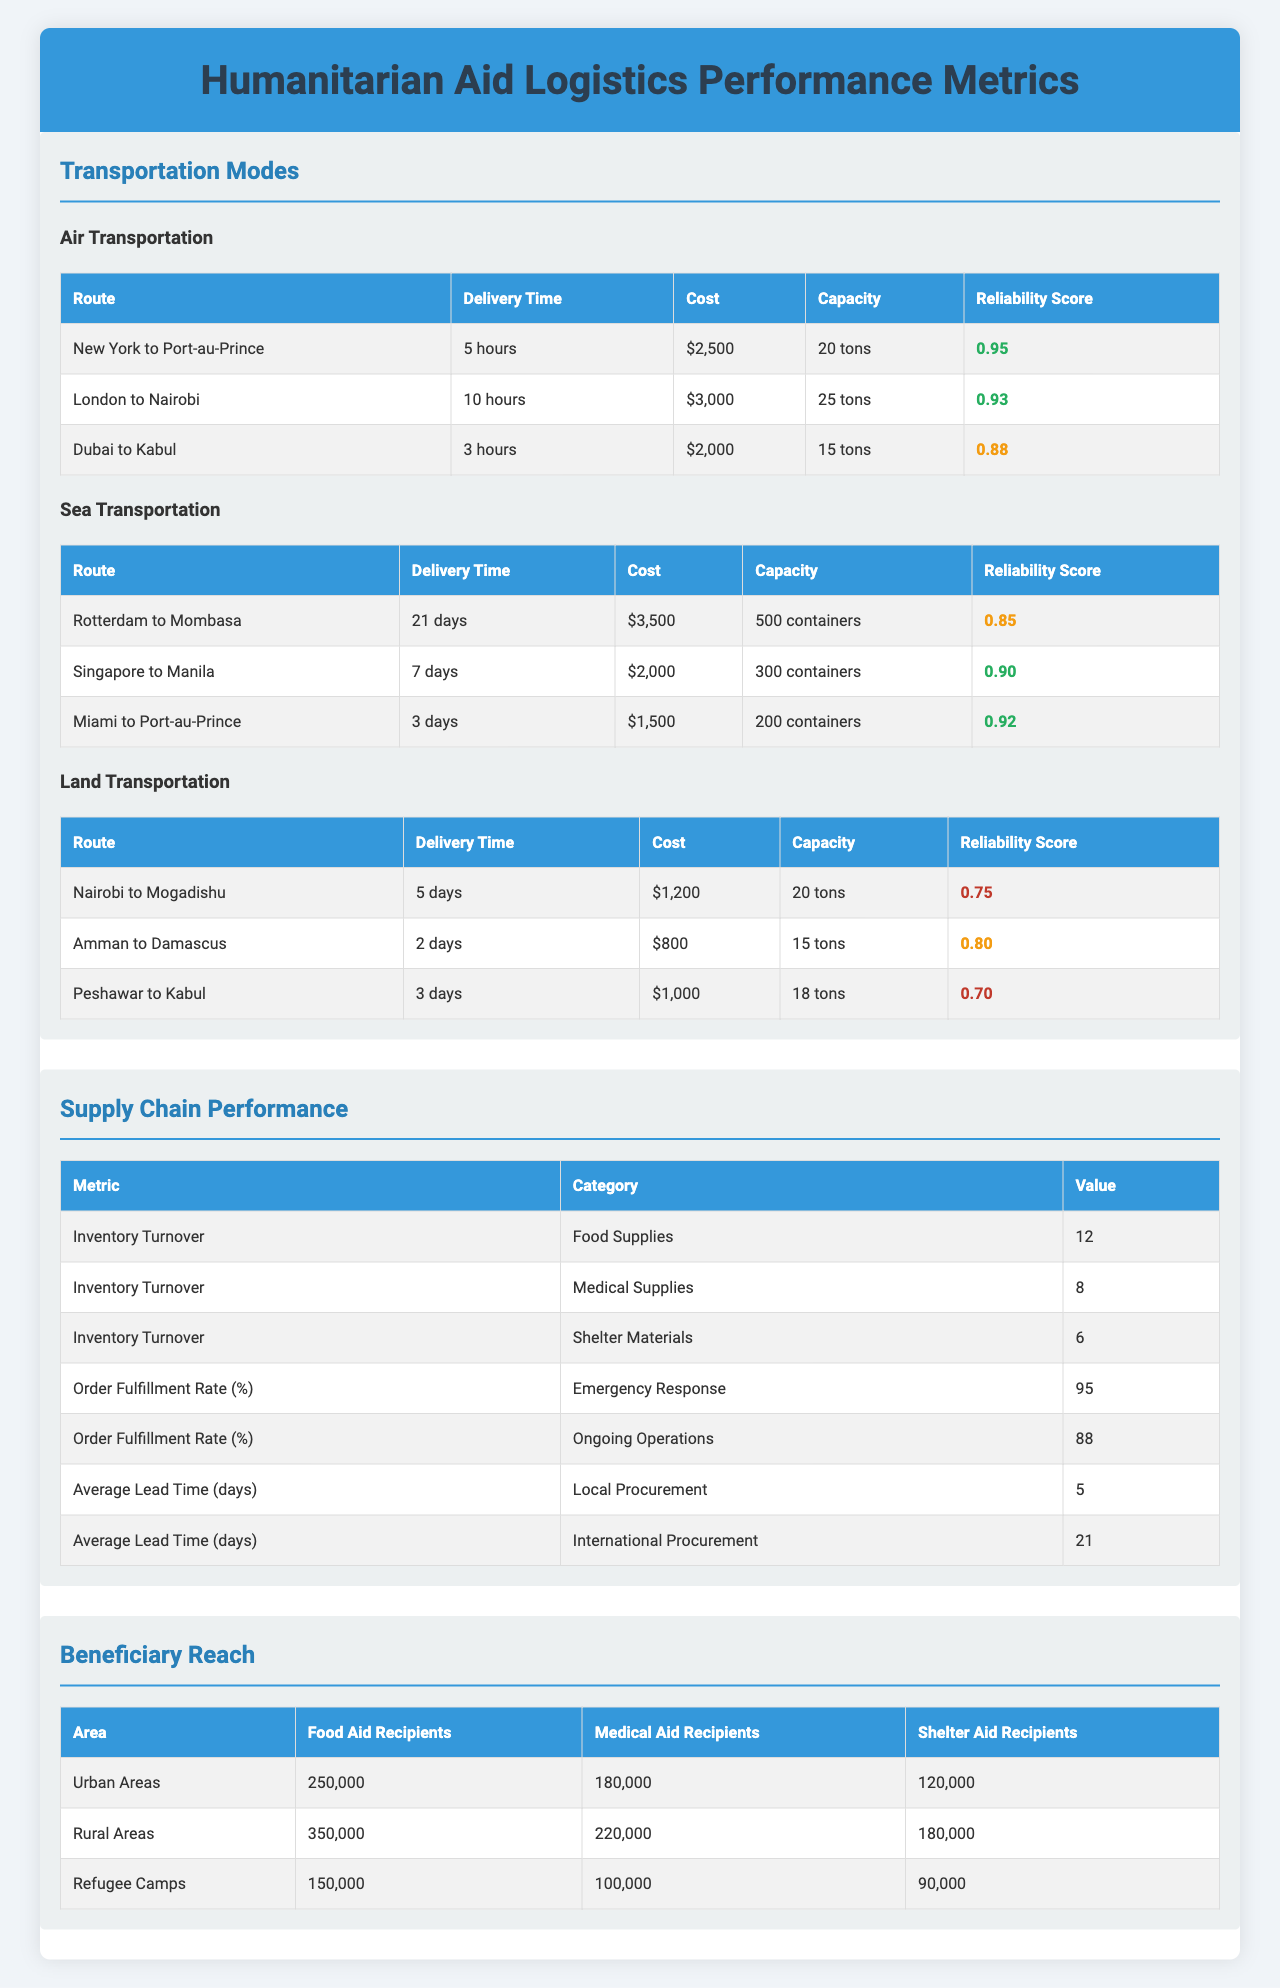What is the delivery time from New York to Port-au-Prince by air? The table lists the delivery time for the "New York to Port-au-Prince" route under the air transportation mode, which is specified as 5 hours.
Answer: 5 hours What is the cost per ton for air transportation from London to Nairobi? The table provides the cost per ton for the "London to Nairobi" route under air transportation, which is given as $3,000.
Answer: $3,000 Which transportation mode has the highest reliability score? The table shows the reliability scores for all transportation modes. Among them, air transportation has the highest score of 0.95 for the "New York to Port-au-Prince" route.
Answer: Air How many food aid recipients are there in urban areas? The "Beneficiary Reach" section of the table provides the number of food aid recipients in urban areas as 250,000.
Answer: 250,000 What is the average delivery time for sea transportation? The delivery times listed for sea transportation are 21 days for "Rotterdam to Mombasa," 7 days for "Singapore to Manila," and 3 days for "Miami to Port-au-Prince." The average is (21 + 7 + 3) / 3 = 10.33 days.
Answer: 10.33 days Which route has the lowest reliability score in land transportation? In the land transportation section, the route "Peshawar to Kabul" has the lowest reliability score of 0.70, compared to the other routes listed.
Answer: Peshawar to Kabul What is the total number of medical aid recipients in rural areas and refugee camps? The table shows 220,000 medical aid recipients in rural areas and 100,000 in refugee camps. Adding these gives a total of 220,000 + 100,000 = 320,000 medical aid recipients.
Answer: 320,000 Is the delivery cost for sea transportation from Miami to Port-au-Prince less than $1,500? According to the table, the delivery cost from Miami to Port-au-Prince by sea transportation is $1,500, which is not less than $1,500.
Answer: No What is the difference in capacity between air transportation from Dubai to Kabul and land transportation from Nairobi to Mogadishu? The capacity for air transportation from Dubai to Kabul is 15 tons, and for land transportation from Nairobi to Mogadishu, it is 20 tons. The difference is 20 - 15 = 5 tons.
Answer: 5 tons Which route has the shortest delivery time overall, and what is that time? Reviewing the delivery times listed, the shortest delivery time is from Dubai to Kabul by air at 3 hours, which is mentioned in the air transportation section.
Answer: 3 hours 